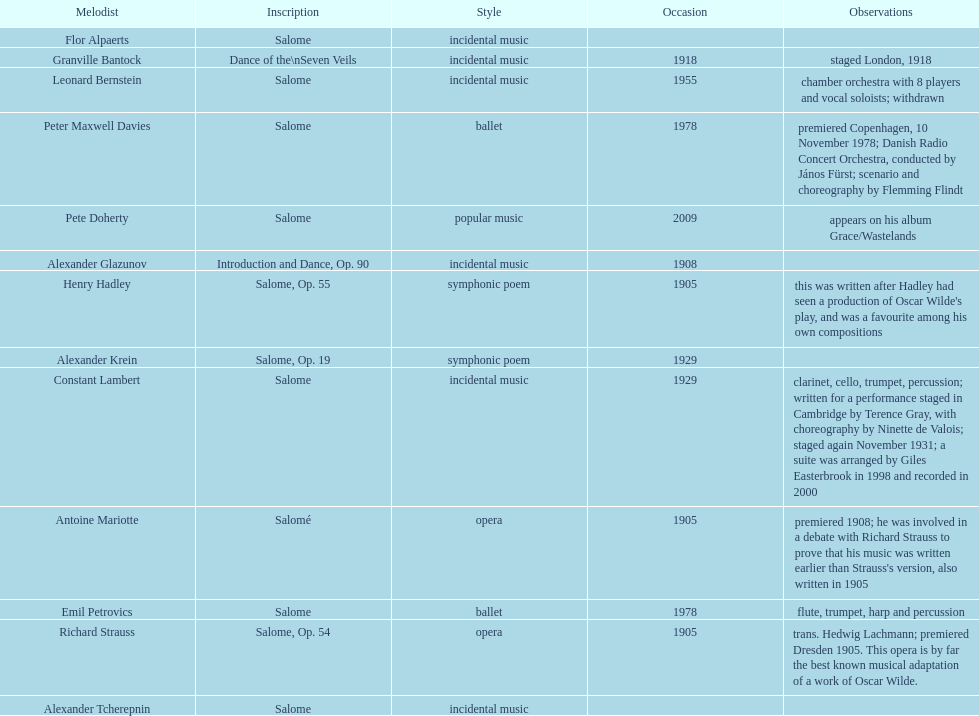What work was written after henry hadley had seen an oscar wilde play? Salome, Op. 55. 